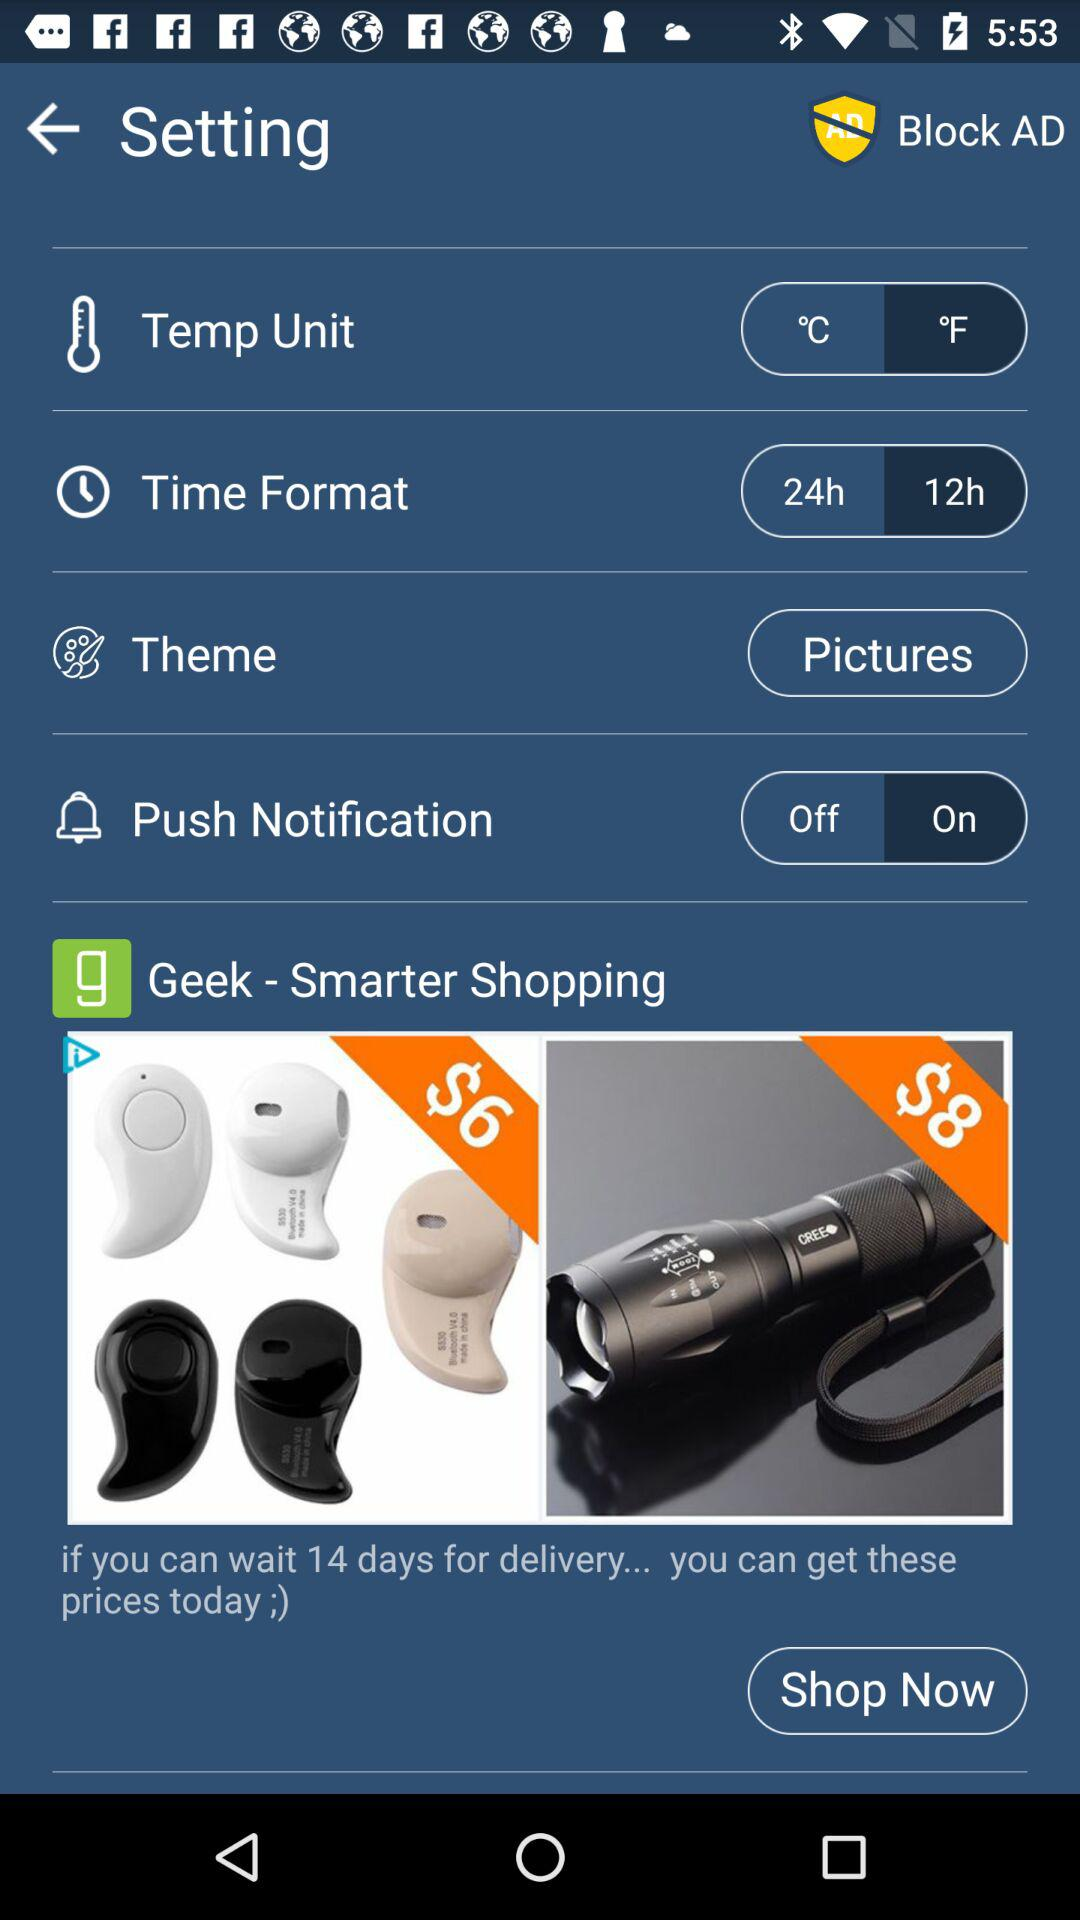Which temperature units are there? The temperature units are °C and °F. 